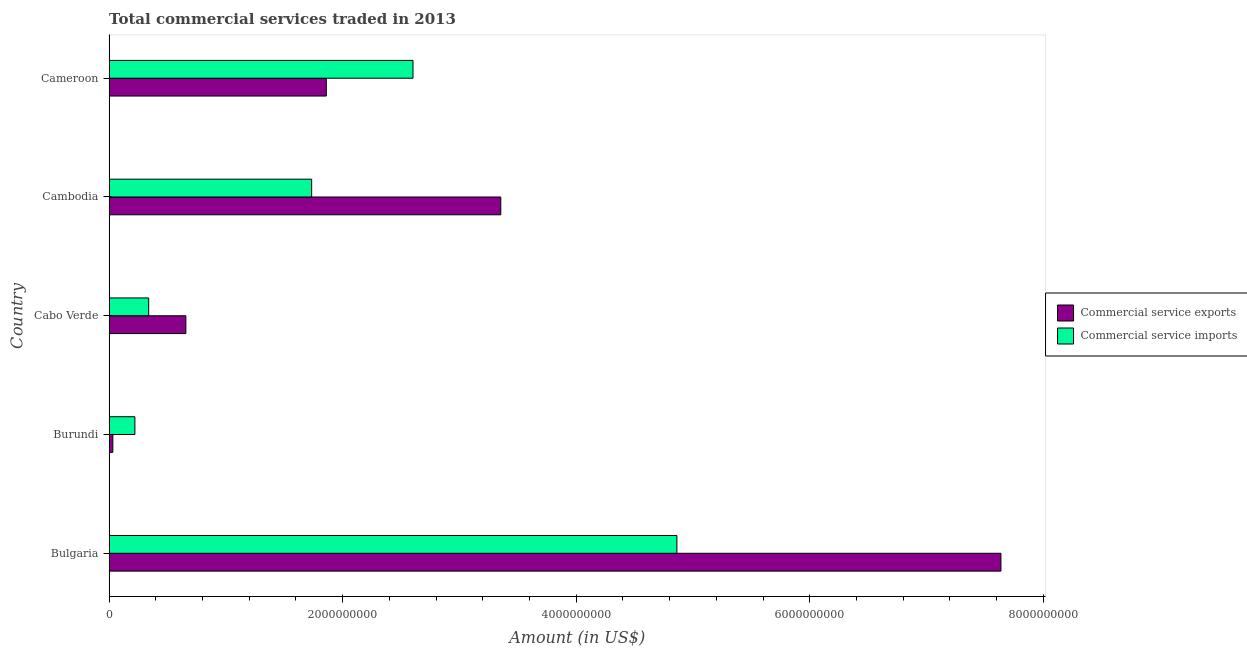How many different coloured bars are there?
Your answer should be very brief. 2. How many groups of bars are there?
Your response must be concise. 5. Are the number of bars on each tick of the Y-axis equal?
Keep it short and to the point. Yes. What is the label of the 1st group of bars from the top?
Your response must be concise. Cameroon. In how many cases, is the number of bars for a given country not equal to the number of legend labels?
Make the answer very short. 0. What is the amount of commercial service exports in Burundi?
Your response must be concise. 3.23e+07. Across all countries, what is the maximum amount of commercial service imports?
Provide a short and direct response. 4.86e+09. Across all countries, what is the minimum amount of commercial service exports?
Offer a very short reply. 3.23e+07. In which country was the amount of commercial service exports maximum?
Provide a succinct answer. Bulgaria. In which country was the amount of commercial service imports minimum?
Your answer should be compact. Burundi. What is the total amount of commercial service imports in the graph?
Your response must be concise. 9.76e+09. What is the difference between the amount of commercial service exports in Burundi and that in Cameroon?
Offer a very short reply. -1.83e+09. What is the difference between the amount of commercial service exports in Bulgaria and the amount of commercial service imports in Cambodia?
Offer a terse response. 5.90e+09. What is the average amount of commercial service imports per country?
Make the answer very short. 1.95e+09. What is the difference between the amount of commercial service exports and amount of commercial service imports in Cameroon?
Provide a short and direct response. -7.42e+08. In how many countries, is the amount of commercial service exports greater than 1200000000 US$?
Provide a succinct answer. 3. What is the ratio of the amount of commercial service imports in Burundi to that in Cameroon?
Make the answer very short. 0.09. Is the difference between the amount of commercial service imports in Cambodia and Cameroon greater than the difference between the amount of commercial service exports in Cambodia and Cameroon?
Offer a terse response. No. What is the difference between the highest and the second highest amount of commercial service imports?
Provide a short and direct response. 2.26e+09. What is the difference between the highest and the lowest amount of commercial service imports?
Provide a short and direct response. 4.64e+09. In how many countries, is the amount of commercial service exports greater than the average amount of commercial service exports taken over all countries?
Your answer should be compact. 2. Is the sum of the amount of commercial service imports in Cabo Verde and Cameroon greater than the maximum amount of commercial service exports across all countries?
Ensure brevity in your answer.  No. What does the 2nd bar from the top in Burundi represents?
Provide a short and direct response. Commercial service exports. What does the 2nd bar from the bottom in Cameroon represents?
Provide a short and direct response. Commercial service imports. How many bars are there?
Make the answer very short. 10. What is the difference between two consecutive major ticks on the X-axis?
Make the answer very short. 2.00e+09. Are the values on the major ticks of X-axis written in scientific E-notation?
Your answer should be compact. No. Does the graph contain any zero values?
Your response must be concise. No. Where does the legend appear in the graph?
Offer a terse response. Center right. How many legend labels are there?
Keep it short and to the point. 2. How are the legend labels stacked?
Offer a terse response. Vertical. What is the title of the graph?
Your answer should be very brief. Total commercial services traded in 2013. What is the label or title of the Y-axis?
Your response must be concise. Country. What is the Amount (in US$) in Commercial service exports in Bulgaria?
Provide a short and direct response. 7.64e+09. What is the Amount (in US$) in Commercial service imports in Bulgaria?
Give a very brief answer. 4.86e+09. What is the Amount (in US$) in Commercial service exports in Burundi?
Your response must be concise. 3.23e+07. What is the Amount (in US$) in Commercial service imports in Burundi?
Offer a terse response. 2.21e+08. What is the Amount (in US$) in Commercial service exports in Cabo Verde?
Your answer should be very brief. 6.58e+08. What is the Amount (in US$) in Commercial service imports in Cabo Verde?
Provide a short and direct response. 3.39e+08. What is the Amount (in US$) in Commercial service exports in Cambodia?
Your answer should be very brief. 3.35e+09. What is the Amount (in US$) of Commercial service imports in Cambodia?
Your answer should be compact. 1.73e+09. What is the Amount (in US$) in Commercial service exports in Cameroon?
Ensure brevity in your answer.  1.86e+09. What is the Amount (in US$) in Commercial service imports in Cameroon?
Make the answer very short. 2.60e+09. Across all countries, what is the maximum Amount (in US$) in Commercial service exports?
Provide a short and direct response. 7.64e+09. Across all countries, what is the maximum Amount (in US$) in Commercial service imports?
Keep it short and to the point. 4.86e+09. Across all countries, what is the minimum Amount (in US$) in Commercial service exports?
Offer a very short reply. 3.23e+07. Across all countries, what is the minimum Amount (in US$) in Commercial service imports?
Provide a short and direct response. 2.21e+08. What is the total Amount (in US$) in Commercial service exports in the graph?
Ensure brevity in your answer.  1.35e+1. What is the total Amount (in US$) of Commercial service imports in the graph?
Your answer should be compact. 9.76e+09. What is the difference between the Amount (in US$) in Commercial service exports in Bulgaria and that in Burundi?
Your response must be concise. 7.60e+09. What is the difference between the Amount (in US$) in Commercial service imports in Bulgaria and that in Burundi?
Your answer should be very brief. 4.64e+09. What is the difference between the Amount (in US$) in Commercial service exports in Bulgaria and that in Cabo Verde?
Your answer should be compact. 6.98e+09. What is the difference between the Amount (in US$) in Commercial service imports in Bulgaria and that in Cabo Verde?
Your answer should be compact. 4.52e+09. What is the difference between the Amount (in US$) of Commercial service exports in Bulgaria and that in Cambodia?
Keep it short and to the point. 4.28e+09. What is the difference between the Amount (in US$) in Commercial service imports in Bulgaria and that in Cambodia?
Ensure brevity in your answer.  3.13e+09. What is the difference between the Amount (in US$) of Commercial service exports in Bulgaria and that in Cameroon?
Provide a succinct answer. 5.78e+09. What is the difference between the Amount (in US$) in Commercial service imports in Bulgaria and that in Cameroon?
Offer a very short reply. 2.26e+09. What is the difference between the Amount (in US$) in Commercial service exports in Burundi and that in Cabo Verde?
Give a very brief answer. -6.25e+08. What is the difference between the Amount (in US$) in Commercial service imports in Burundi and that in Cabo Verde?
Offer a terse response. -1.18e+08. What is the difference between the Amount (in US$) in Commercial service exports in Burundi and that in Cambodia?
Give a very brief answer. -3.32e+09. What is the difference between the Amount (in US$) in Commercial service imports in Burundi and that in Cambodia?
Offer a very short reply. -1.51e+09. What is the difference between the Amount (in US$) of Commercial service exports in Burundi and that in Cameroon?
Provide a succinct answer. -1.83e+09. What is the difference between the Amount (in US$) of Commercial service imports in Burundi and that in Cameroon?
Your response must be concise. -2.38e+09. What is the difference between the Amount (in US$) of Commercial service exports in Cabo Verde and that in Cambodia?
Your answer should be very brief. -2.70e+09. What is the difference between the Amount (in US$) in Commercial service imports in Cabo Verde and that in Cambodia?
Give a very brief answer. -1.40e+09. What is the difference between the Amount (in US$) in Commercial service exports in Cabo Verde and that in Cameroon?
Offer a very short reply. -1.20e+09. What is the difference between the Amount (in US$) of Commercial service imports in Cabo Verde and that in Cameroon?
Keep it short and to the point. -2.26e+09. What is the difference between the Amount (in US$) of Commercial service exports in Cambodia and that in Cameroon?
Make the answer very short. 1.49e+09. What is the difference between the Amount (in US$) in Commercial service imports in Cambodia and that in Cameroon?
Keep it short and to the point. -8.68e+08. What is the difference between the Amount (in US$) in Commercial service exports in Bulgaria and the Amount (in US$) in Commercial service imports in Burundi?
Your answer should be very brief. 7.42e+09. What is the difference between the Amount (in US$) in Commercial service exports in Bulgaria and the Amount (in US$) in Commercial service imports in Cabo Verde?
Offer a terse response. 7.30e+09. What is the difference between the Amount (in US$) of Commercial service exports in Bulgaria and the Amount (in US$) of Commercial service imports in Cambodia?
Ensure brevity in your answer.  5.90e+09. What is the difference between the Amount (in US$) in Commercial service exports in Bulgaria and the Amount (in US$) in Commercial service imports in Cameroon?
Provide a short and direct response. 5.03e+09. What is the difference between the Amount (in US$) in Commercial service exports in Burundi and the Amount (in US$) in Commercial service imports in Cabo Verde?
Your answer should be very brief. -3.07e+08. What is the difference between the Amount (in US$) in Commercial service exports in Burundi and the Amount (in US$) in Commercial service imports in Cambodia?
Make the answer very short. -1.70e+09. What is the difference between the Amount (in US$) in Commercial service exports in Burundi and the Amount (in US$) in Commercial service imports in Cameroon?
Offer a very short reply. -2.57e+09. What is the difference between the Amount (in US$) in Commercial service exports in Cabo Verde and the Amount (in US$) in Commercial service imports in Cambodia?
Your answer should be very brief. -1.08e+09. What is the difference between the Amount (in US$) of Commercial service exports in Cabo Verde and the Amount (in US$) of Commercial service imports in Cameroon?
Your answer should be compact. -1.94e+09. What is the difference between the Amount (in US$) of Commercial service exports in Cambodia and the Amount (in US$) of Commercial service imports in Cameroon?
Provide a succinct answer. 7.52e+08. What is the average Amount (in US$) of Commercial service exports per country?
Ensure brevity in your answer.  2.71e+09. What is the average Amount (in US$) in Commercial service imports per country?
Provide a short and direct response. 1.95e+09. What is the difference between the Amount (in US$) of Commercial service exports and Amount (in US$) of Commercial service imports in Bulgaria?
Make the answer very short. 2.77e+09. What is the difference between the Amount (in US$) in Commercial service exports and Amount (in US$) in Commercial service imports in Burundi?
Give a very brief answer. -1.89e+08. What is the difference between the Amount (in US$) in Commercial service exports and Amount (in US$) in Commercial service imports in Cabo Verde?
Provide a succinct answer. 3.18e+08. What is the difference between the Amount (in US$) of Commercial service exports and Amount (in US$) of Commercial service imports in Cambodia?
Offer a terse response. 1.62e+09. What is the difference between the Amount (in US$) in Commercial service exports and Amount (in US$) in Commercial service imports in Cameroon?
Give a very brief answer. -7.42e+08. What is the ratio of the Amount (in US$) in Commercial service exports in Bulgaria to that in Burundi?
Provide a succinct answer. 236.19. What is the ratio of the Amount (in US$) in Commercial service imports in Bulgaria to that in Burundi?
Make the answer very short. 21.99. What is the ratio of the Amount (in US$) of Commercial service exports in Bulgaria to that in Cabo Verde?
Your response must be concise. 11.61. What is the ratio of the Amount (in US$) in Commercial service imports in Bulgaria to that in Cabo Verde?
Ensure brevity in your answer.  14.33. What is the ratio of the Amount (in US$) of Commercial service exports in Bulgaria to that in Cambodia?
Provide a short and direct response. 2.28. What is the ratio of the Amount (in US$) in Commercial service imports in Bulgaria to that in Cambodia?
Provide a succinct answer. 2.8. What is the ratio of the Amount (in US$) of Commercial service exports in Bulgaria to that in Cameroon?
Keep it short and to the point. 4.11. What is the ratio of the Amount (in US$) of Commercial service imports in Bulgaria to that in Cameroon?
Keep it short and to the point. 1.87. What is the ratio of the Amount (in US$) of Commercial service exports in Burundi to that in Cabo Verde?
Keep it short and to the point. 0.05. What is the ratio of the Amount (in US$) of Commercial service imports in Burundi to that in Cabo Verde?
Your answer should be very brief. 0.65. What is the ratio of the Amount (in US$) of Commercial service exports in Burundi to that in Cambodia?
Keep it short and to the point. 0.01. What is the ratio of the Amount (in US$) in Commercial service imports in Burundi to that in Cambodia?
Keep it short and to the point. 0.13. What is the ratio of the Amount (in US$) of Commercial service exports in Burundi to that in Cameroon?
Offer a terse response. 0.02. What is the ratio of the Amount (in US$) in Commercial service imports in Burundi to that in Cameroon?
Provide a short and direct response. 0.08. What is the ratio of the Amount (in US$) of Commercial service exports in Cabo Verde to that in Cambodia?
Provide a short and direct response. 0.2. What is the ratio of the Amount (in US$) of Commercial service imports in Cabo Verde to that in Cambodia?
Give a very brief answer. 0.2. What is the ratio of the Amount (in US$) of Commercial service exports in Cabo Verde to that in Cameroon?
Provide a succinct answer. 0.35. What is the ratio of the Amount (in US$) of Commercial service imports in Cabo Verde to that in Cameroon?
Your answer should be compact. 0.13. What is the ratio of the Amount (in US$) of Commercial service exports in Cambodia to that in Cameroon?
Your answer should be compact. 1.8. What is the ratio of the Amount (in US$) of Commercial service imports in Cambodia to that in Cameroon?
Your answer should be very brief. 0.67. What is the difference between the highest and the second highest Amount (in US$) of Commercial service exports?
Provide a short and direct response. 4.28e+09. What is the difference between the highest and the second highest Amount (in US$) of Commercial service imports?
Offer a terse response. 2.26e+09. What is the difference between the highest and the lowest Amount (in US$) of Commercial service exports?
Provide a short and direct response. 7.60e+09. What is the difference between the highest and the lowest Amount (in US$) in Commercial service imports?
Provide a succinct answer. 4.64e+09. 